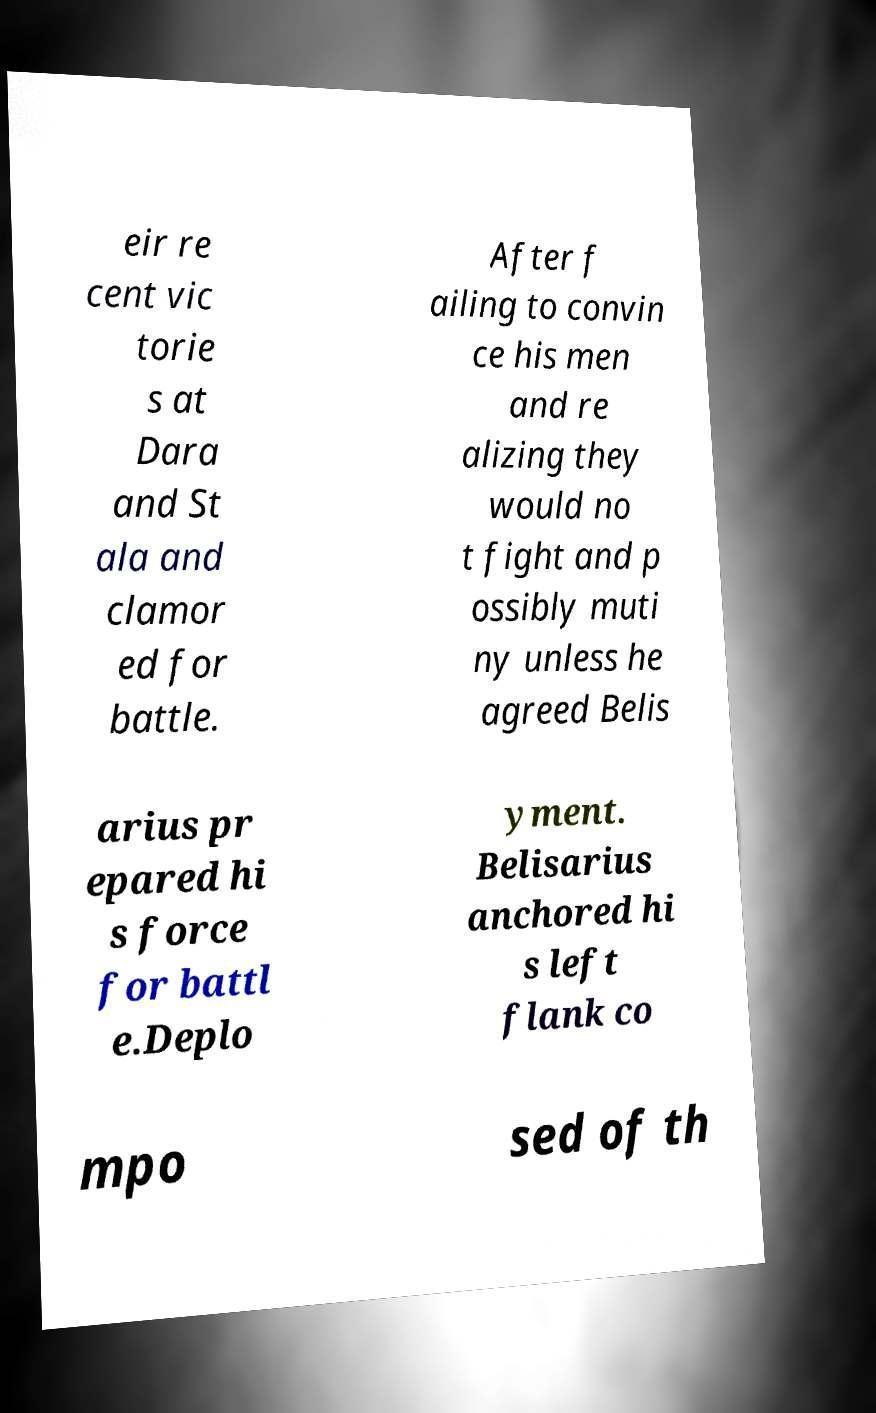There's text embedded in this image that I need extracted. Can you transcribe it verbatim? eir re cent vic torie s at Dara and St ala and clamor ed for battle. After f ailing to convin ce his men and re alizing they would no t fight and p ossibly muti ny unless he agreed Belis arius pr epared hi s force for battl e.Deplo yment. Belisarius anchored hi s left flank co mpo sed of th 